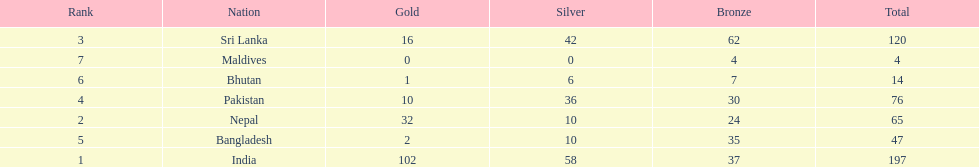Which nation has earned the least amount of gold medals? Maldives. 